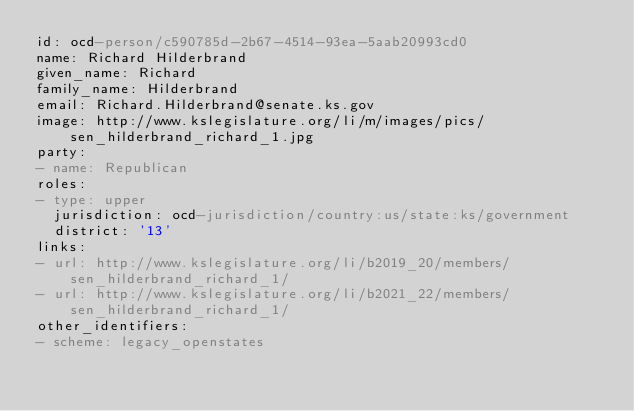Convert code to text. <code><loc_0><loc_0><loc_500><loc_500><_YAML_>id: ocd-person/c590785d-2b67-4514-93ea-5aab20993cd0
name: Richard Hilderbrand
given_name: Richard
family_name: Hilderbrand
email: Richard.Hilderbrand@senate.ks.gov
image: http://www.kslegislature.org/li/m/images/pics/sen_hilderbrand_richard_1.jpg
party:
- name: Republican
roles:
- type: upper
  jurisdiction: ocd-jurisdiction/country:us/state:ks/government
  district: '13'
links:
- url: http://www.kslegislature.org/li/b2019_20/members/sen_hilderbrand_richard_1/
- url: http://www.kslegislature.org/li/b2021_22/members/sen_hilderbrand_richard_1/
other_identifiers:
- scheme: legacy_openstates</code> 